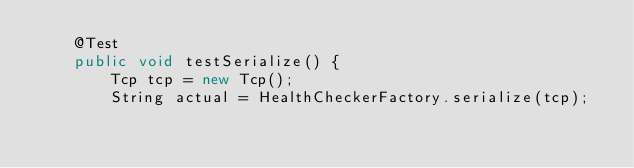<code> <loc_0><loc_0><loc_500><loc_500><_Java_>    @Test
    public void testSerialize() {
        Tcp tcp = new Tcp();
        String actual = HealthCheckerFactory.serialize(tcp);</code> 